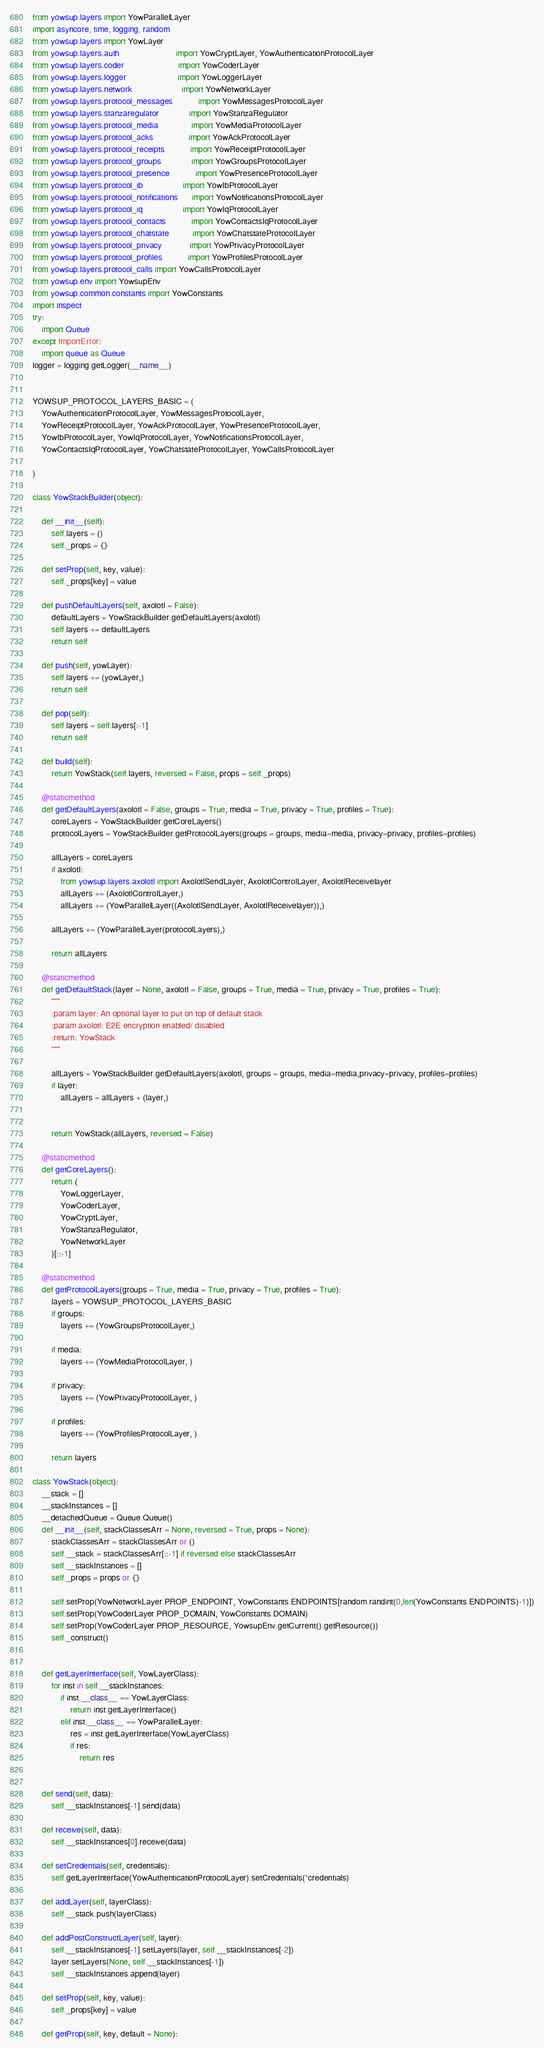<code> <loc_0><loc_0><loc_500><loc_500><_Python_>from yowsup.layers import YowParallelLayer
import asyncore, time, logging, random
from yowsup.layers import YowLayer
from yowsup.layers.auth                        import YowCryptLayer, YowAuthenticationProtocolLayer
from yowsup.layers.coder                       import YowCoderLayer
from yowsup.layers.logger                      import YowLoggerLayer
from yowsup.layers.network                     import YowNetworkLayer
from yowsup.layers.protocol_messages           import YowMessagesProtocolLayer
from yowsup.layers.stanzaregulator             import YowStanzaRegulator
from yowsup.layers.protocol_media              import YowMediaProtocolLayer
from yowsup.layers.protocol_acks               import YowAckProtocolLayer
from yowsup.layers.protocol_receipts           import YowReceiptProtocolLayer
from yowsup.layers.protocol_groups             import YowGroupsProtocolLayer
from yowsup.layers.protocol_presence           import YowPresenceProtocolLayer
from yowsup.layers.protocol_ib                 import YowIbProtocolLayer
from yowsup.layers.protocol_notifications      import YowNotificationsProtocolLayer
from yowsup.layers.protocol_iq                 import YowIqProtocolLayer
from yowsup.layers.protocol_contacts           import YowContactsIqProtocolLayer
from yowsup.layers.protocol_chatstate          import YowChatstateProtocolLayer
from yowsup.layers.protocol_privacy            import YowPrivacyProtocolLayer
from yowsup.layers.protocol_profiles           import YowProfilesProtocolLayer
from yowsup.layers.protocol_calls import YowCallsProtocolLayer
from yowsup.env import YowsupEnv
from yowsup.common.constants import YowConstants
import inspect
try:
    import Queue
except ImportError:
    import queue as Queue
logger = logging.getLogger(__name__)


YOWSUP_PROTOCOL_LAYERS_BASIC = (
    YowAuthenticationProtocolLayer, YowMessagesProtocolLayer,
    YowReceiptProtocolLayer, YowAckProtocolLayer, YowPresenceProtocolLayer,
    YowIbProtocolLayer, YowIqProtocolLayer, YowNotificationsProtocolLayer,
    YowContactsIqProtocolLayer, YowChatstateProtocolLayer, YowCallsProtocolLayer

)

class YowStackBuilder(object):

    def __init__(self):
        self.layers = ()
        self._props = {}

    def setProp(self, key, value):
        self._props[key] = value

    def pushDefaultLayers(self, axolotl = False):
        defaultLayers = YowStackBuilder.getDefaultLayers(axolotl)
        self.layers += defaultLayers
        return self

    def push(self, yowLayer):
        self.layers += (yowLayer,)
        return self

    def pop(self):
        self.layers = self.layers[:-1]
        return self

    def build(self):
        return YowStack(self.layers, reversed = False, props = self._props)

    @staticmethod
    def getDefaultLayers(axolotl = False, groups = True, media = True, privacy = True, profiles = True):
        coreLayers = YowStackBuilder.getCoreLayers()
        protocolLayers = YowStackBuilder.getProtocolLayers(groups = groups, media=media, privacy=privacy, profiles=profiles)

        allLayers = coreLayers
        if axolotl:
            from yowsup.layers.axolotl import AxolotlSendLayer, AxolotlControlLayer, AxolotlReceivelayer
            allLayers += (AxolotlControlLayer,)
            allLayers += (YowParallelLayer((AxolotlSendLayer, AxolotlReceivelayer)),)

        allLayers += (YowParallelLayer(protocolLayers),)

        return allLayers

    @staticmethod
    def getDefaultStack(layer = None, axolotl = False, groups = True, media = True, privacy = True, profiles = True):
        """
        :param layer: An optional layer to put on top of default stack
        :param axolotl: E2E encryption enabled/ disabled
        :return: YowStack
        """

        allLayers = YowStackBuilder.getDefaultLayers(axolotl, groups = groups, media=media,privacy=privacy, profiles=profiles)
        if layer:
            allLayers = allLayers + (layer,)


        return YowStack(allLayers, reversed = False)

    @staticmethod
    def getCoreLayers():
        return (
            YowLoggerLayer,
            YowCoderLayer,
            YowCryptLayer,
            YowStanzaRegulator,
            YowNetworkLayer
        )[::-1]

    @staticmethod
    def getProtocolLayers(groups = True, media = True, privacy = True, profiles = True):
        layers = YOWSUP_PROTOCOL_LAYERS_BASIC
        if groups:
            layers += (YowGroupsProtocolLayer,)

        if media:
            layers += (YowMediaProtocolLayer, )

        if privacy:
            layers += (YowPrivacyProtocolLayer, )

        if profiles:
            layers += (YowProfilesProtocolLayer, )

        return layers

class YowStack(object):
    __stack = []
    __stackInstances = []
    __detachedQueue = Queue.Queue()
    def __init__(self, stackClassesArr = None, reversed = True, props = None):
        stackClassesArr = stackClassesArr or ()
        self.__stack = stackClassesArr[::-1] if reversed else stackClassesArr
        self.__stackInstances = []
        self._props = props or {}

        self.setProp(YowNetworkLayer.PROP_ENDPOINT, YowConstants.ENDPOINTS[random.randint(0,len(YowConstants.ENDPOINTS)-1)])
        self.setProp(YowCoderLayer.PROP_DOMAIN, YowConstants.DOMAIN)
        self.setProp(YowCoderLayer.PROP_RESOURCE, YowsupEnv.getCurrent().getResource())
        self._construct()


    def getLayerInterface(self, YowLayerClass):
        for inst in self.__stackInstances:
            if inst.__class__ == YowLayerClass:
                return inst.getLayerInterface()
            elif inst.__class__ == YowParallelLayer:
                res = inst.getLayerInterface(YowLayerClass)
                if res:
                    return res


    def send(self, data):
        self.__stackInstances[-1].send(data)

    def receive(self, data):
        self.__stackInstances[0].receive(data)

    def setCredentials(self, credentials):
        self.getLayerInterface(YowAuthenticationProtocolLayer).setCredentials(*credentials)

    def addLayer(self, layerClass):
        self.__stack.push(layerClass)

    def addPostConstructLayer(self, layer):
        self.__stackInstances[-1].setLayers(layer, self.__stackInstances[-2])
        layer.setLayers(None, self.__stackInstances[-1])
        self.__stackInstances.append(layer)

    def setProp(self, key, value):
        self._props[key] = value

    def getProp(self, key, default = None):</code> 